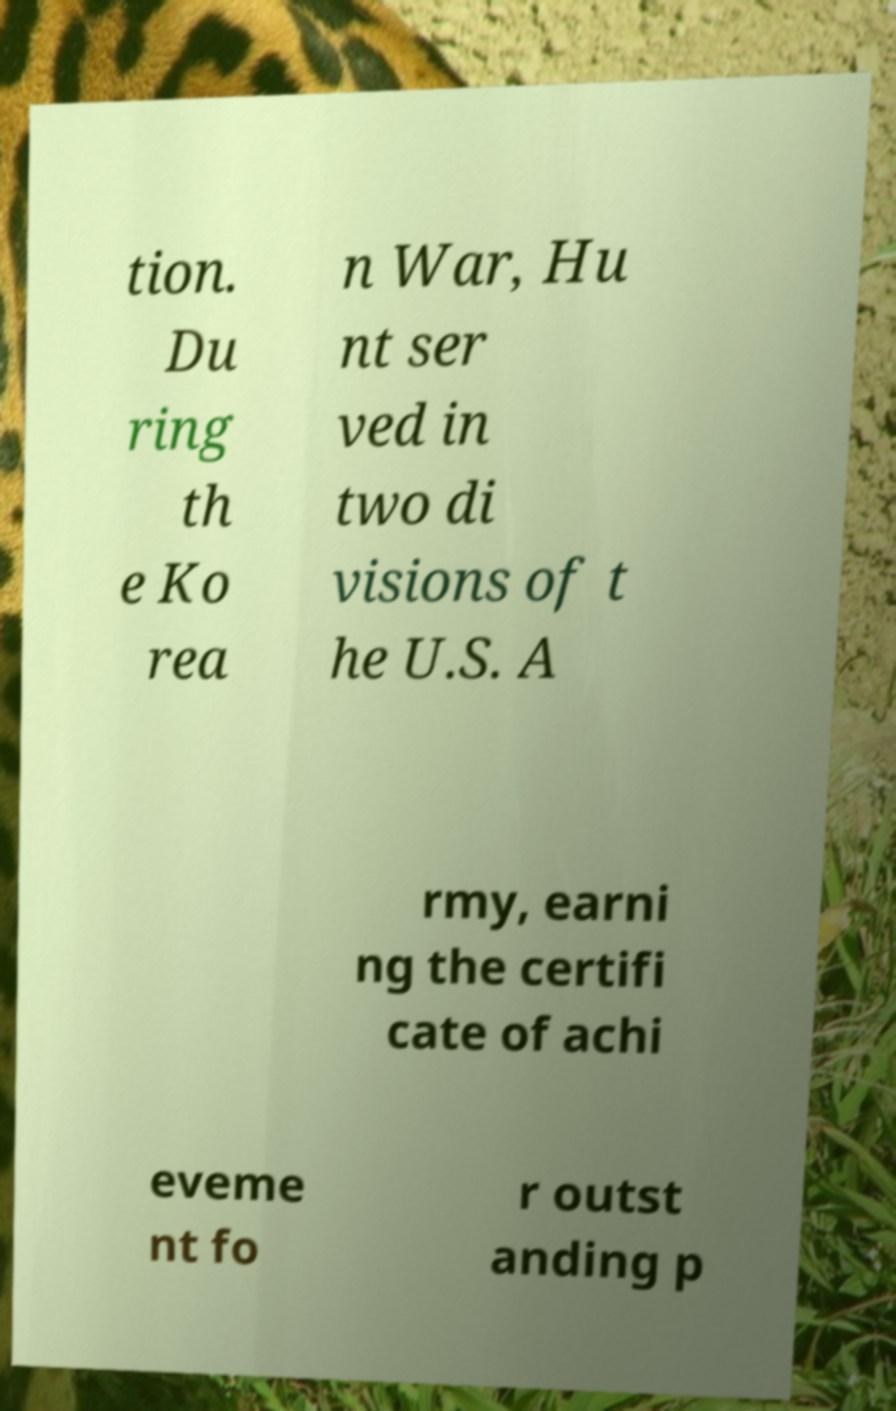Could you assist in decoding the text presented in this image and type it out clearly? tion. Du ring th e Ko rea n War, Hu nt ser ved in two di visions of t he U.S. A rmy, earni ng the certifi cate of achi eveme nt fo r outst anding p 